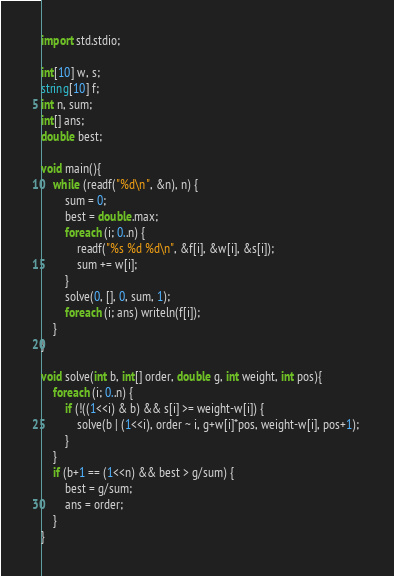<code> <loc_0><loc_0><loc_500><loc_500><_D_>import std.stdio;

int[10] w, s;
string[10] f;
int n, sum;
int[] ans;
double best;

void main(){
	while (readf("%d\n", &n), n) {
		sum = 0;
		best = double.max;
		foreach (i; 0..n) {
			readf("%s %d %d\n", &f[i], &w[i], &s[i]);
			sum += w[i];
		}
		solve(0, [], 0, sum, 1);
		foreach (i; ans) writeln(f[i]);
	}
}

void solve(int b, int[] order, double g, int weight, int pos){
	foreach (i; 0..n) {
		if (!((1<<i) & b) && s[i] >= weight-w[i]) {
			solve(b | (1<<i), order ~ i, g+w[i]*pos, weight-w[i], pos+1); 
		}
	}
	if (b+1 == (1<<n) && best > g/sum) {
		best = g/sum;
		ans = order;
	}
}</code> 